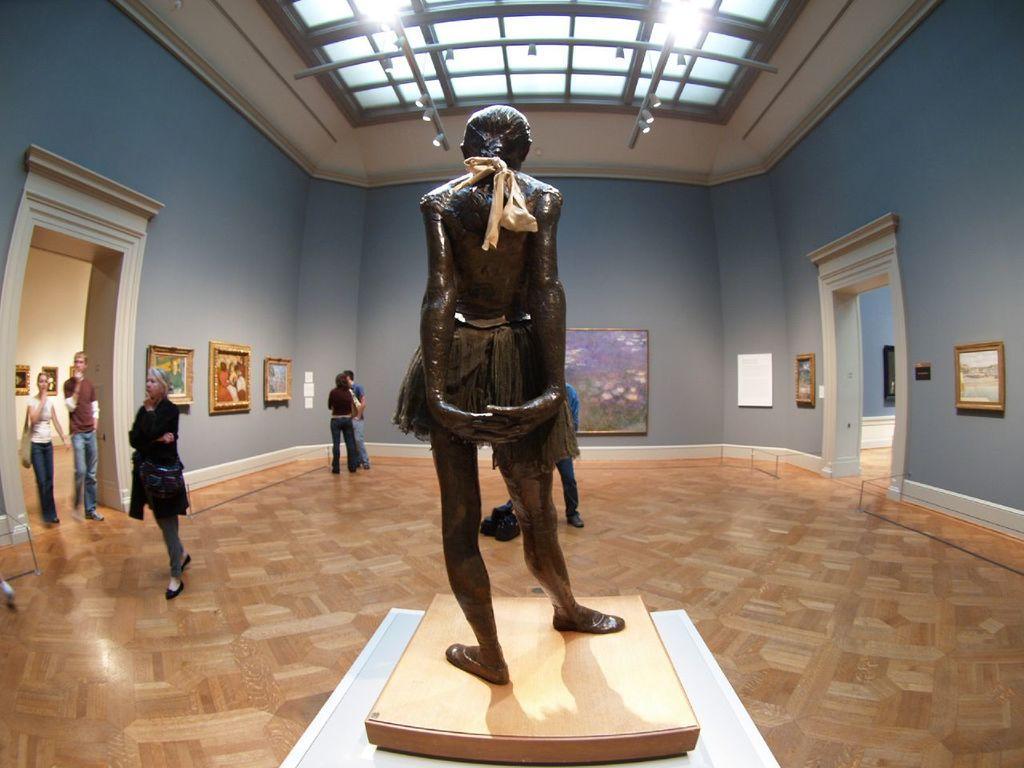In one or two sentences, can you explain what this image depicts? In this image we can see a sculpture, there are groups of persons standing on the floor, there is a wall and photo frames on it, at above there are lights, there is the door. 